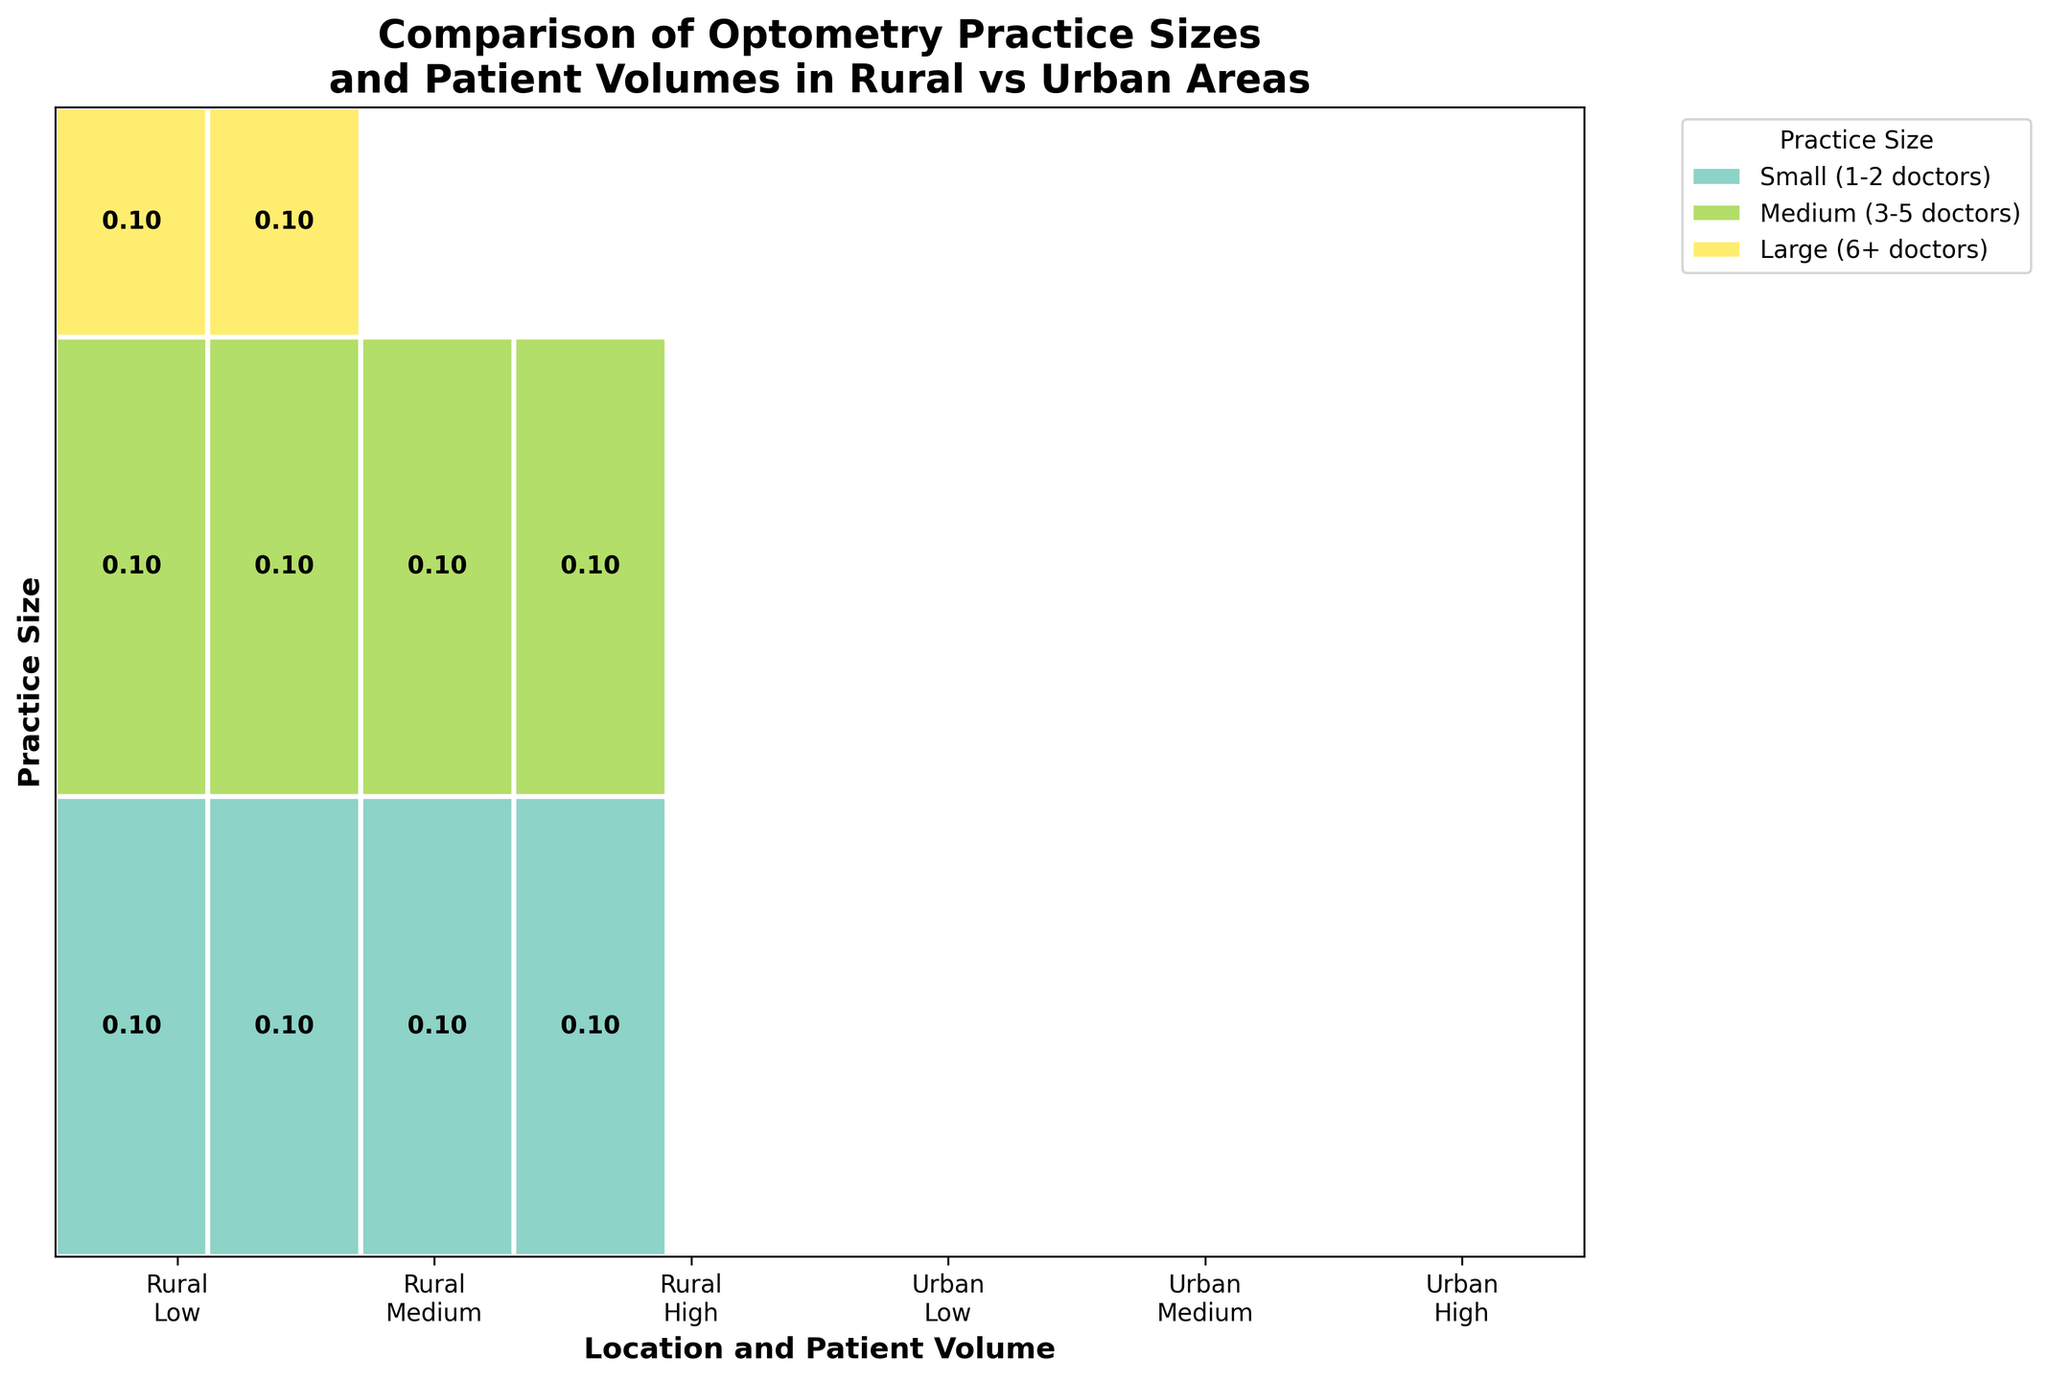Which practice size is most common in urban areas with a high patient volume? The mosaic plot shows the distributions of practice sizes across locations and patient volumes. By looking at the section for Urban and High patient volume, we see that "Large (6+ doctors)" is the most represented practice size in this category.
Answer: Large (6+ doctors) How many distinct combinations of practice size, location, and patient volume are displayed in the mosaic plot? The plot includes three practice sizes (Small, Medium, Large), two locations (Rural, Urban), and three patient volumes (Low, Medium, High). Multiplying these options (3 * 2 * 3) gives the total distinct combinations.
Answer: 18 Which practice size has an equal distribution in both rural and urban areas for medium patient volume? By comparing the segments corresponding to "Medium (3-5 doctors)" under the Medium patient volume in both Rural and Urban areas, we notice they are equal.
Answer: Medium (3-5 doctors) What is the overall proportion of practices in rural areas by looking at the figure? Summing up the heights of the rectangles representing "Rural" for all practice sizes and patient volumes and then normalizing by the total plot area will give the proportion. This estimation can be difficult without precise numbers, but visually summing the heights for Rural areas shows roughly around half of the rectangles, indicating about 50%.
Answer: Approximately 50% Do large practices exist in rural areas with a high patient volume? By observing the Rural section under the High patient volume category, we see no rectangles for Large (6+ doctors), indicating that no large practices exist in this category.
Answer: No Comparing urban areas, which practice size has the lowest patient volume? Observing the sections for urban areas with Low patient volume, we see that there's no representation, implying none. Multi-step reasoning confirms that other practice sizes show representations in Medium and High categories.
Answer: None By practice size, which has the greatest number of combinations with patient volumes and locations? Each practice size can have up to six combinations (2 locations * 3 patient volumes). Observing the plot shows that all practice sizes cover these six combinations. Therefore, each practice size has the same number of combinations.
Answer: Same for all What proportion of the plot does the largest segment for small practices occupy? The largest segment for “Small (1-2 doctors)” appears to be in the Urban with High patient volume. Estimating proportions can vary, but it may occupy roughly one-sixth of the plot.
Answer: Approximately one-sixth 